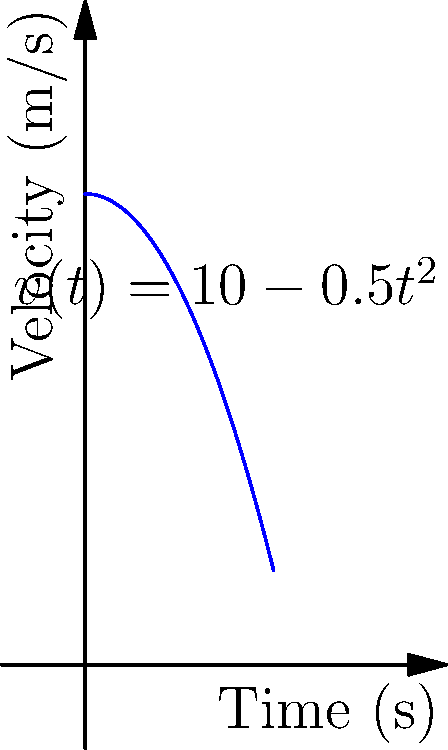As a professional sprinter, you're analyzing your race performance. The velocity-time curve for your 100m sprint is given by the function $v(t) = 10 - 0.5t^2$, where $v$ is in meters per second and $t$ is in seconds. Calculate the distance you traveled during the first 4 seconds of the race. To solve this problem, we need to calculate the area under the velocity-time curve from $t=0$ to $t=4$. This can be done using integration:

1) The distance traveled is given by the integral of velocity with respect to time:

   $d = \int_0^4 v(t) dt$

2) Substitute the given function:

   $d = \int_0^4 (10 - 0.5t^2) dt$

3) Integrate the function:

   $d = [10t - \frac{1}{6}t^3]_0^4$

4) Evaluate the integral at the limits:

   $d = (40 - \frac{64}{6}) - (0 - 0)$

5) Simplify:

   $d = 40 - \frac{32}{3} = \frac{120}{3} - \frac{32}{3} = \frac{88}{3}$

Therefore, the distance traveled in the first 4 seconds is $\frac{88}{3}$ meters.
Answer: $\frac{88}{3}$ meters 